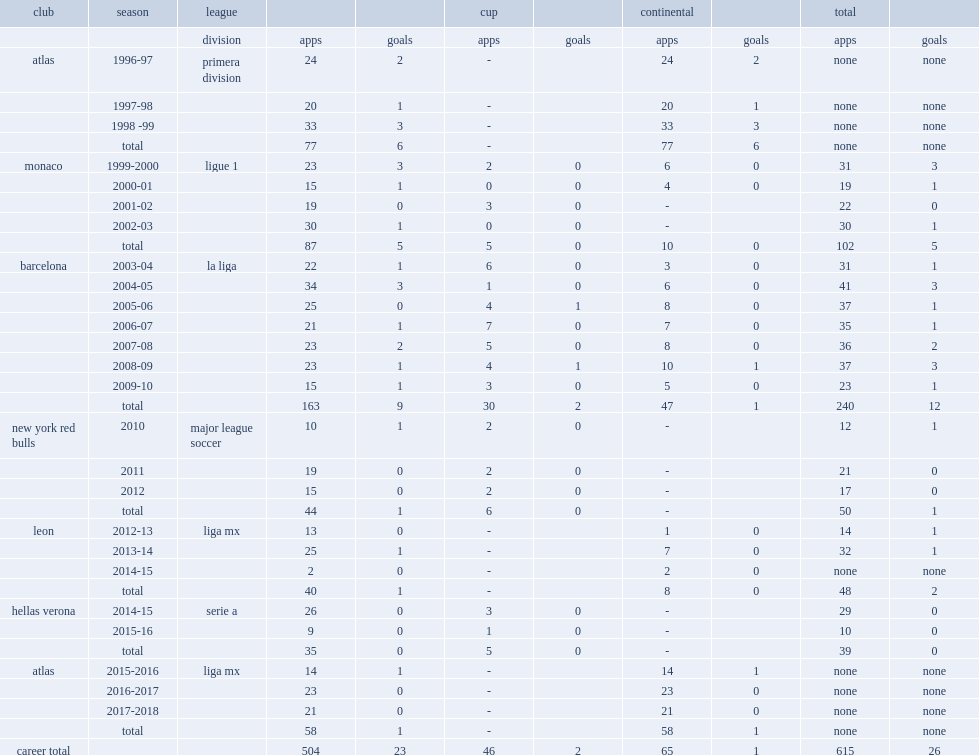Which club did marquez sign for major league soccer? New york red bulls. 